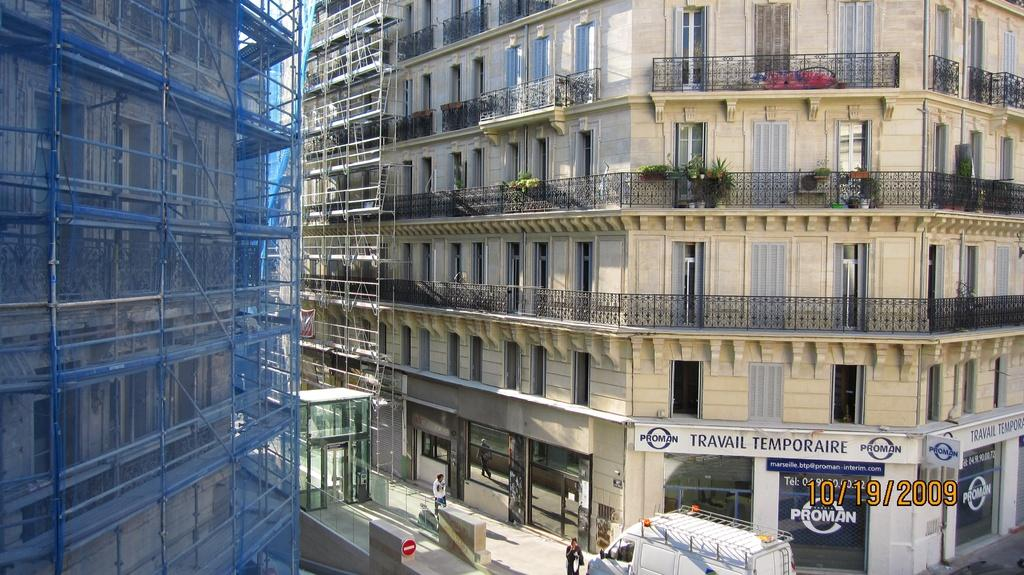What type of structure is located on the right side of the image? There is a big building on the right side of the image. What can be found at the bottom of the image? There appears to be a store at the bottom of the image. What activity is taking place on the left side of the image? Construction is taking place on the left side of the image. What type of veil can be seen covering the construction site on the left side of the image? There is no veil present in the image; the construction site is visible without any covering. What type of quartz is used as a decorative element in the big building on the right side of the image? There is no mention of quartz or any decorative elements in the big building; the fact only states that there is a big building on the right side of the image. 